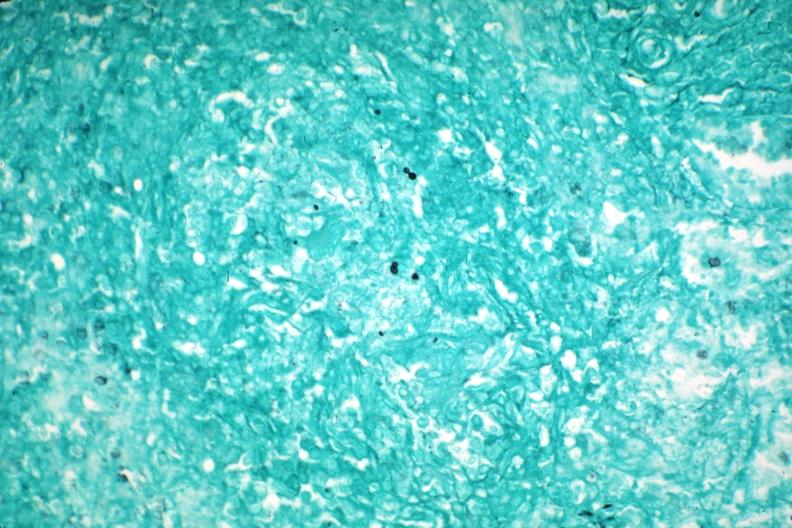s spleen present?
Answer the question using a single word or phrase. Yes 